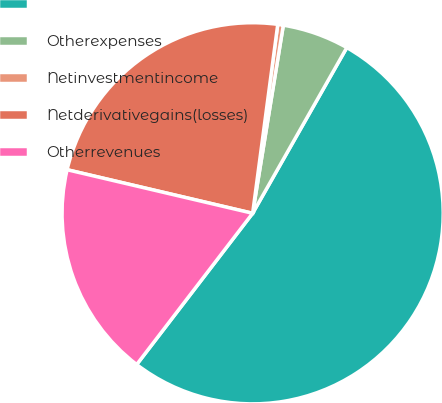<chart> <loc_0><loc_0><loc_500><loc_500><pie_chart><ecel><fcel>Otherexpenses<fcel>Netinvestmentincome<fcel>Netderivativegains(losses)<fcel>Otherrevenues<nl><fcel>52.18%<fcel>5.65%<fcel>0.47%<fcel>23.43%<fcel>18.26%<nl></chart> 